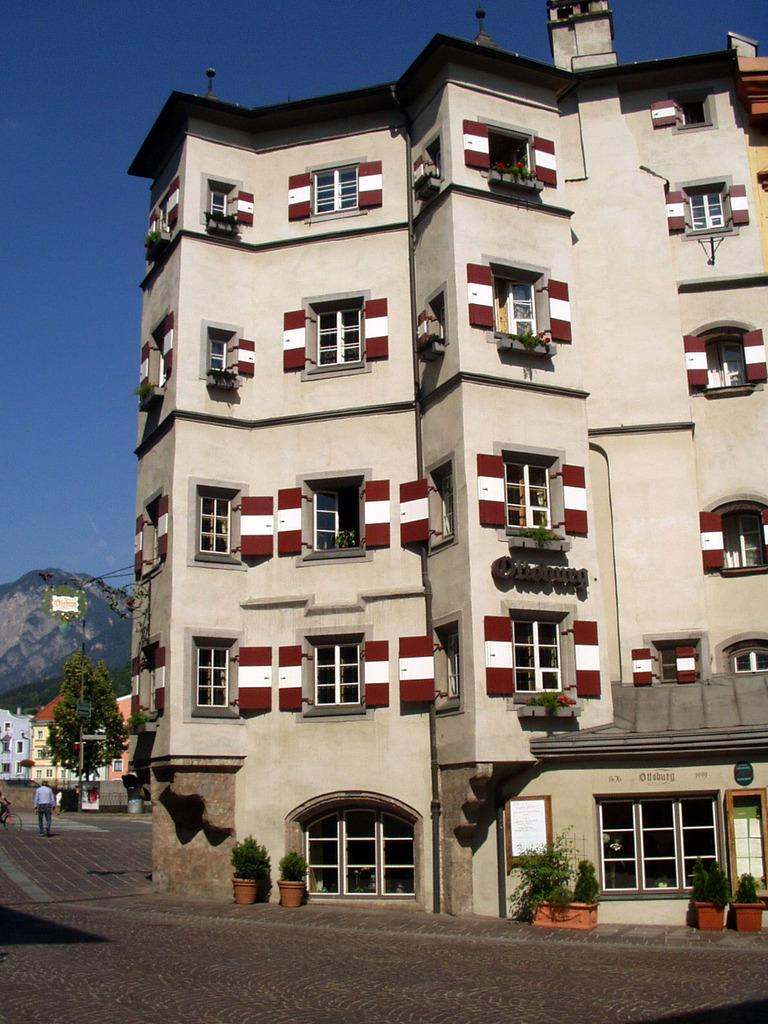What type of structures can be seen in the image? There are buildings in the image. What natural element is present in the image? There is a tree in the image. Can you describe the person in the image? There is a person standing on the road in the image. What geographical feature is visible in the image? There are mountains visible in the image. What type of plants are near the building in the image? There are potted plants in front of the building in the image. What is visible in the background of the image? The sky is visible in the background of the image. What type of instrument is being played by the person standing on the road in the image? There is no instrument being played by the person in the image; they are simply standing on the road. Can you describe the steam coming from the mountains in the image? There is no steam coming from the mountains in the image; the mountains are visible in the distance without any steam or smoke. 